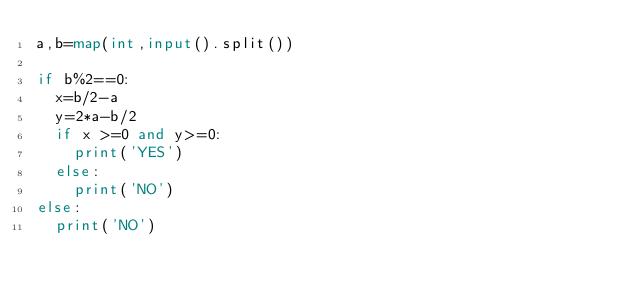Convert code to text. <code><loc_0><loc_0><loc_500><loc_500><_Python_>a,b=map(int,input().split())

if b%2==0:
  x=b/2-a
  y=2*a-b/2
  if x >=0 and y>=0:
    print('YES')
  else:
    print('NO')
else:
  print('NO')</code> 